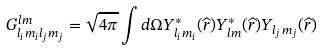Convert formula to latex. <formula><loc_0><loc_0><loc_500><loc_500>G ^ { l m } _ { l _ { i } m _ { i } l _ { j } m _ { j } } = \sqrt { 4 \pi } \int d \Omega Y _ { l _ { i } m _ { i } } ^ { * } ( \widehat { r } ) Y _ { l m } ^ { * } ( \widehat { r } ) Y _ { l _ { j } m _ { j } } ( \widehat { r } )</formula> 